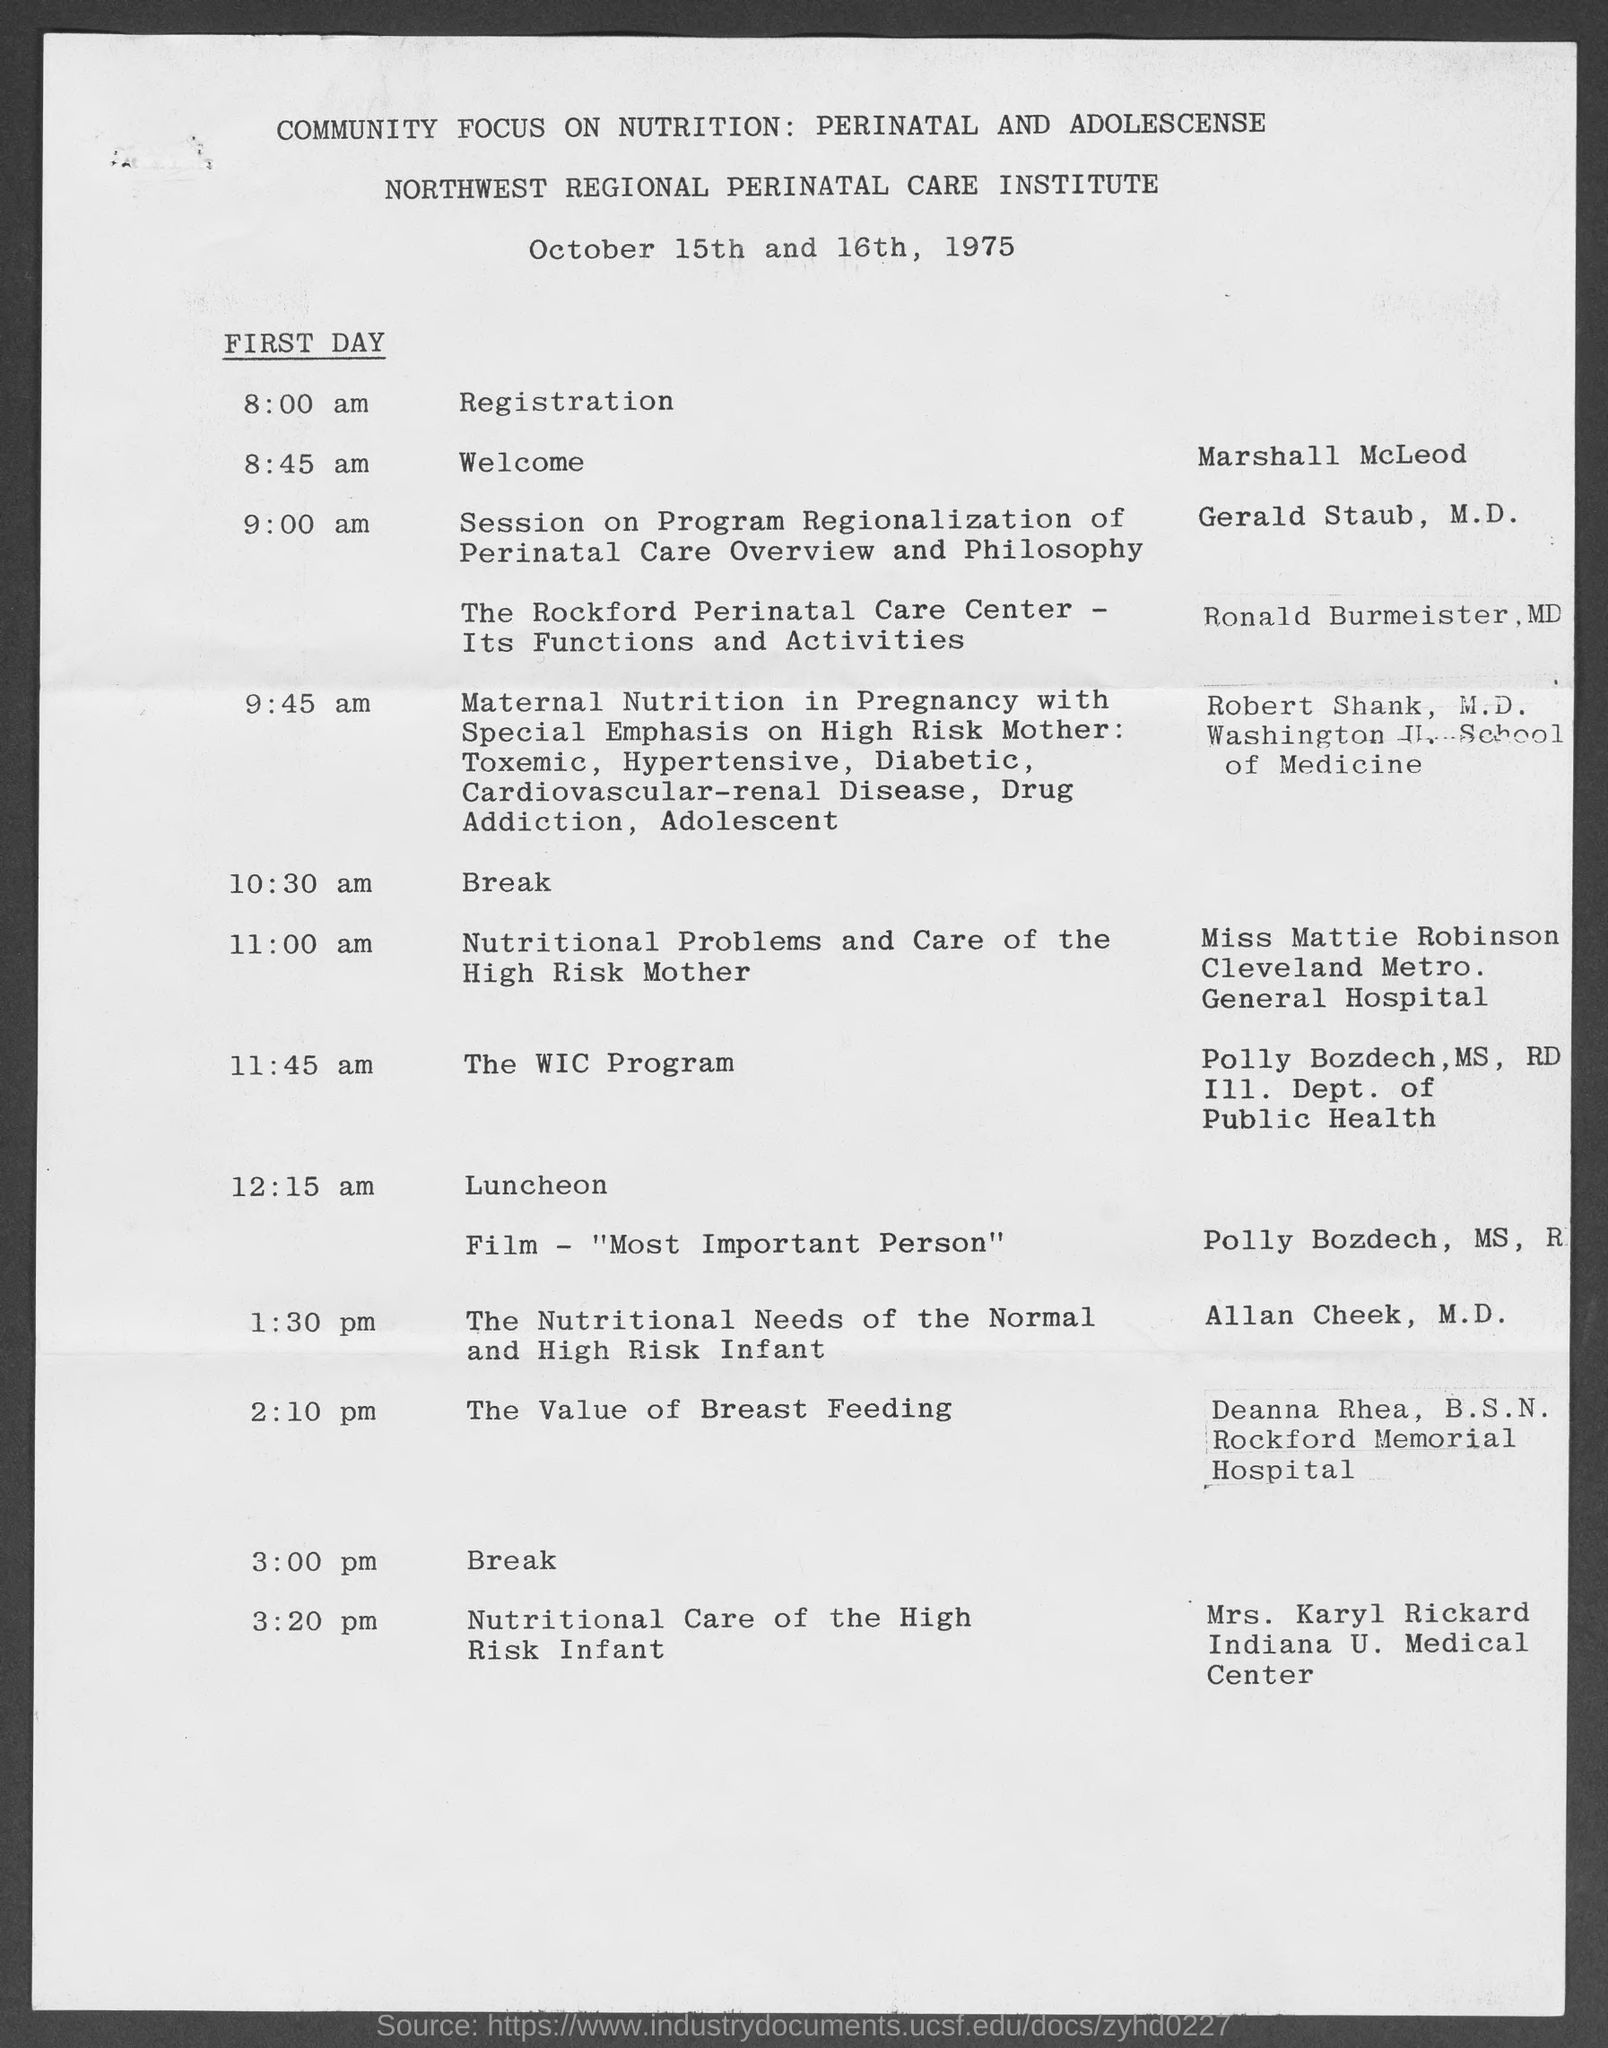List a handful of essential elements in this visual. The topic of Mrs. Karyl Rickard is the nutritional care of high-risk infants. The film that is to be shown is 'Most Important Person.' The Northwest Regional Perinatal Care Institute is mentioned. Deanna Rhea, who holds a Bachelor of Science in Nursing degree from Rockford Memorial Hospital, is from that institution. On the first day at 8:45 am, Marshall McLeod will be welcomed by someone. 